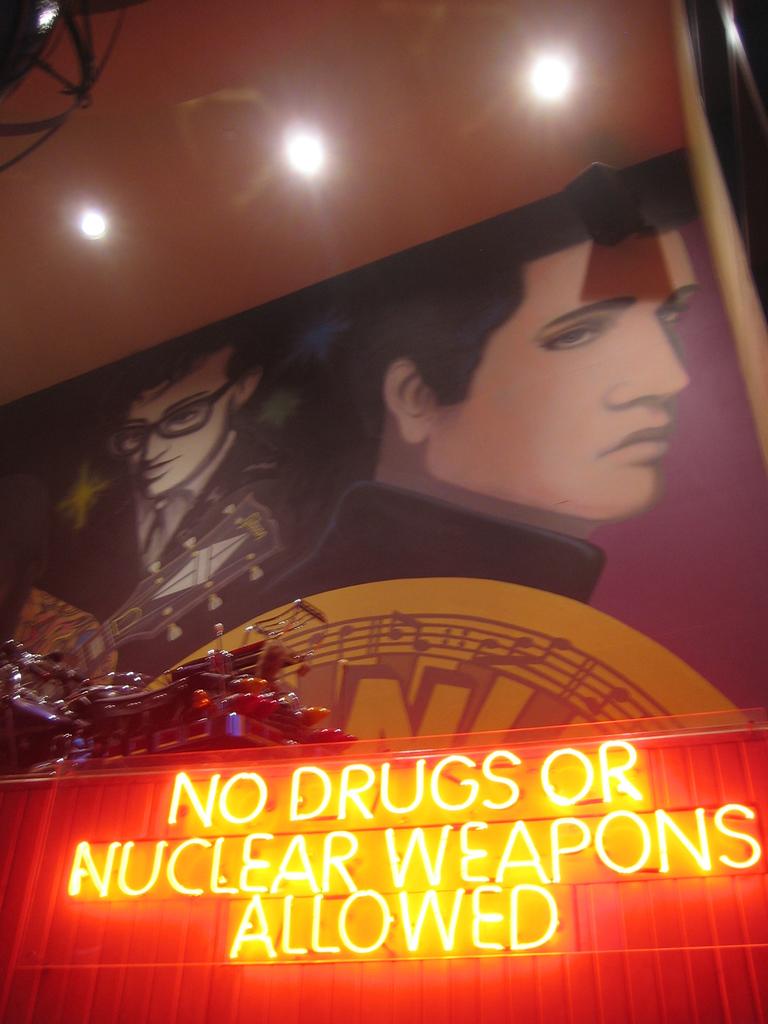What is written in neon?
Your answer should be compact. No drugs or nuclear weapons allowed. 